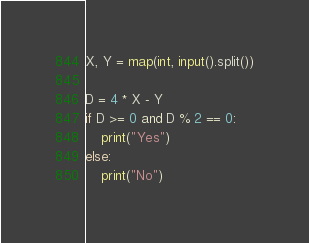<code> <loc_0><loc_0><loc_500><loc_500><_Python_>X, Y = map(int, input().split())

D = 4 * X - Y
if D >= 0 and D % 2 == 0:
    print("Yes")
else:
    print("No")
</code> 